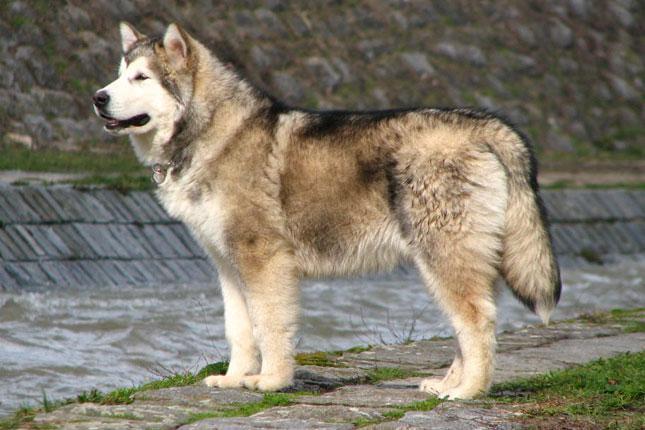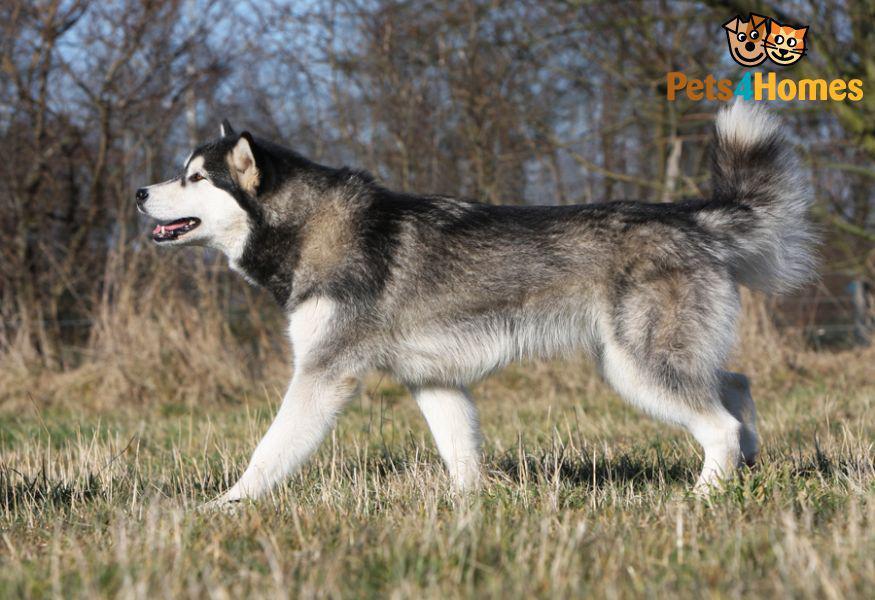The first image is the image on the left, the second image is the image on the right. For the images shown, is this caption "Every photo shows exactly one dog, facing left, photographed outside, and not being accompanied by a human." true? Answer yes or no. Yes. 